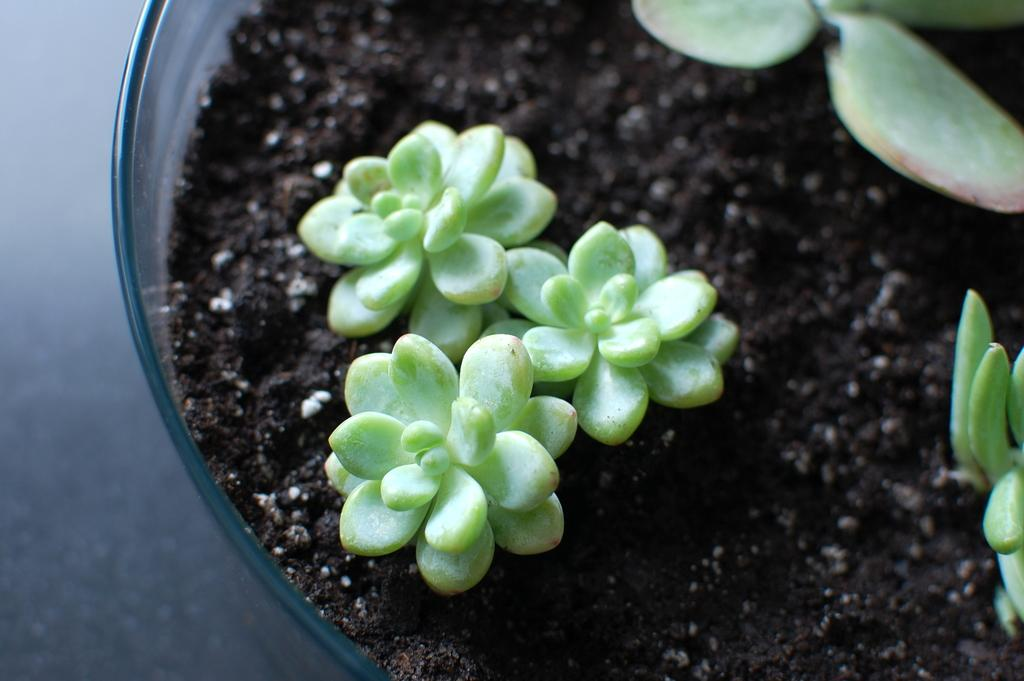What is located in the image? There is a bowl in the image. Where is the bowl placed? The bowl is on a platform. What is inside the bowl? There is soil in the bowl. What is growing in the soil? There are plants in the bowl. Can you see a kitty playing with a line in the image? There is no kitty or line present in the image. What type of camera is used to capture the image? The type of camera used to capture the image is not mentioned in the provided facts. 